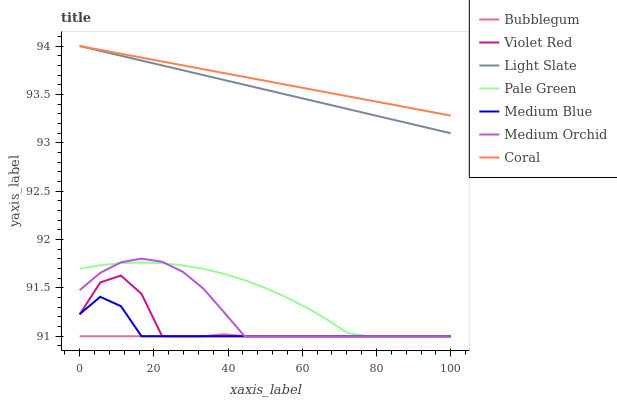Does Bubblegum have the minimum area under the curve?
Answer yes or no. Yes. Does Coral have the maximum area under the curve?
Answer yes or no. Yes. Does Light Slate have the minimum area under the curve?
Answer yes or no. No. Does Light Slate have the maximum area under the curve?
Answer yes or no. No. Is Coral the smoothest?
Answer yes or no. Yes. Is Violet Red the roughest?
Answer yes or no. Yes. Is Light Slate the smoothest?
Answer yes or no. No. Is Light Slate the roughest?
Answer yes or no. No. Does Violet Red have the lowest value?
Answer yes or no. Yes. Does Light Slate have the lowest value?
Answer yes or no. No. Does Coral have the highest value?
Answer yes or no. Yes. Does Medium Orchid have the highest value?
Answer yes or no. No. Is Medium Orchid less than Light Slate?
Answer yes or no. Yes. Is Coral greater than Medium Blue?
Answer yes or no. Yes. Does Bubblegum intersect Medium Orchid?
Answer yes or no. Yes. Is Bubblegum less than Medium Orchid?
Answer yes or no. No. Is Bubblegum greater than Medium Orchid?
Answer yes or no. No. Does Medium Orchid intersect Light Slate?
Answer yes or no. No. 